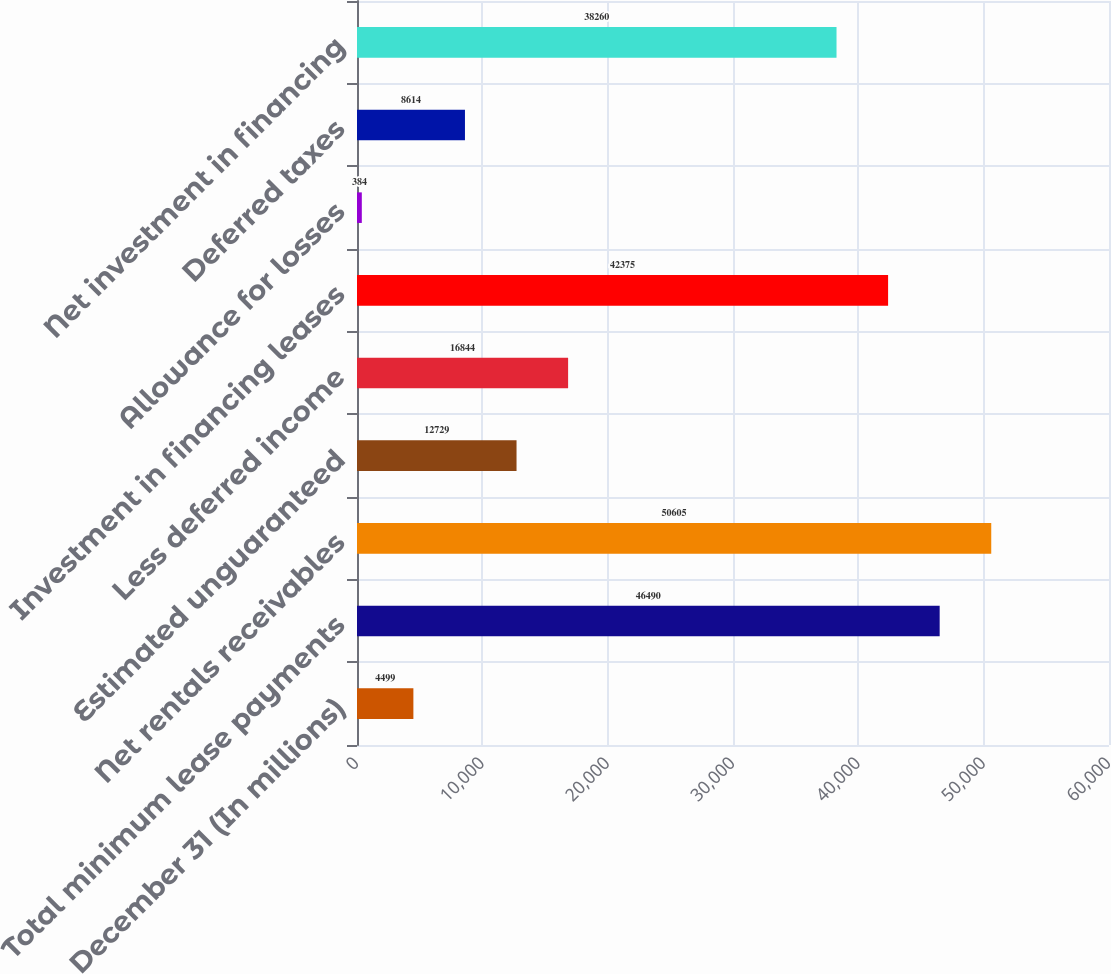Convert chart. <chart><loc_0><loc_0><loc_500><loc_500><bar_chart><fcel>December 31 (In millions)<fcel>Total minimum lease payments<fcel>Net rentals receivables<fcel>Estimated unguaranteed<fcel>Less deferred income<fcel>Investment in financing leases<fcel>Allowance for losses<fcel>Deferred taxes<fcel>Net investment in financing<nl><fcel>4499<fcel>46490<fcel>50605<fcel>12729<fcel>16844<fcel>42375<fcel>384<fcel>8614<fcel>38260<nl></chart> 